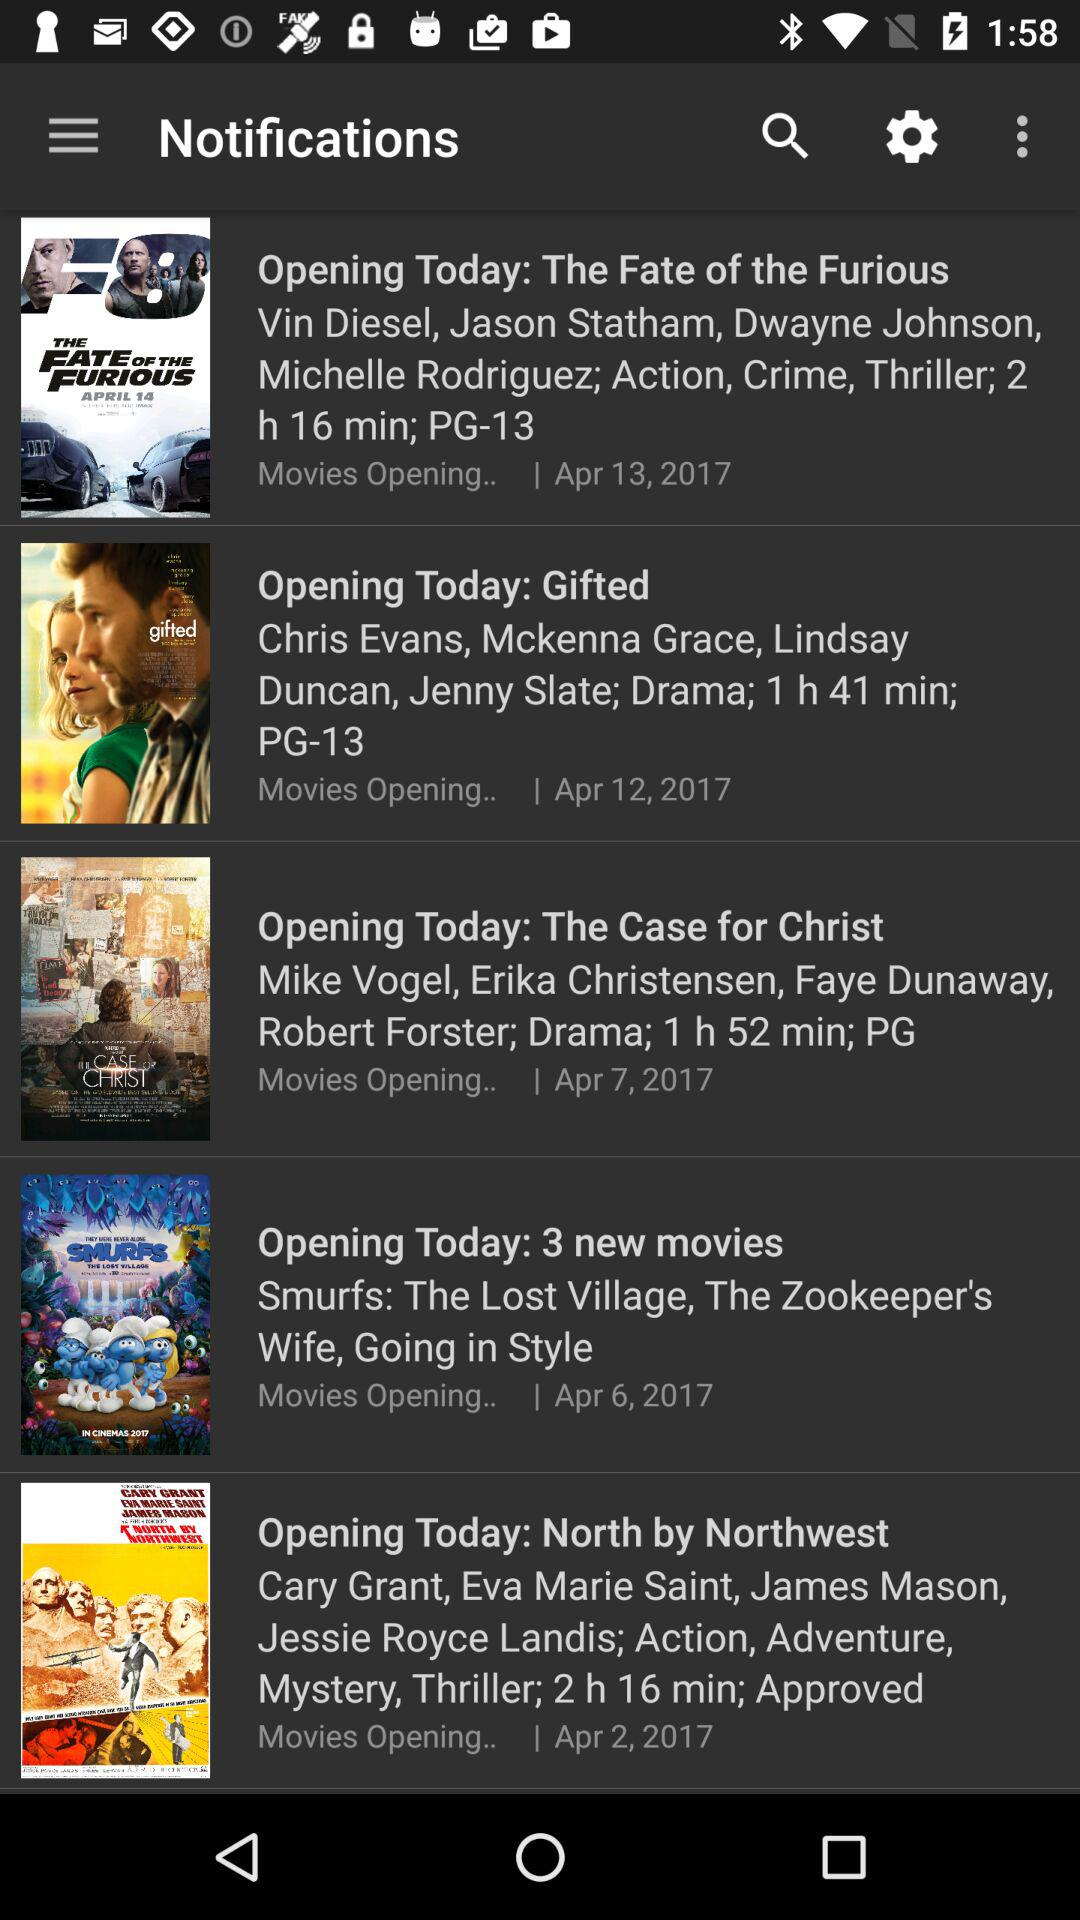What is the duration of the "Gifted" movie? The duration of the "Gifted" movie is 1 hour 41 minutes. 